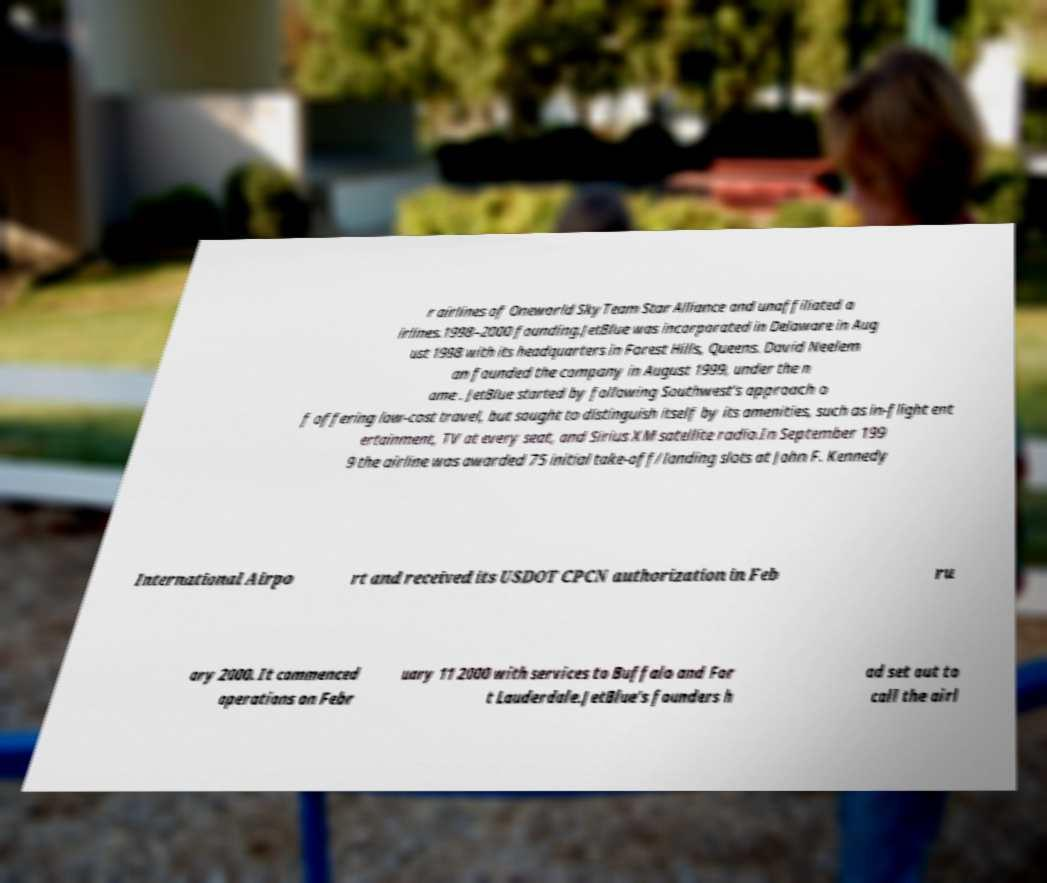Can you accurately transcribe the text from the provided image for me? r airlines of Oneworld SkyTeam Star Alliance and unaffiliated a irlines.1998–2000 founding.JetBlue was incorporated in Delaware in Aug ust 1998 with its headquarters in Forest Hills, Queens. David Neelem an founded the company in August 1999, under the n ame . JetBlue started by following Southwest's approach o f offering low-cost travel, but sought to distinguish itself by its amenities, such as in-flight ent ertainment, TV at every seat, and Sirius XM satellite radio.In September 199 9 the airline was awarded 75 initial take-off/landing slots at John F. Kennedy International Airpo rt and received its USDOT CPCN authorization in Feb ru ary 2000. It commenced operations on Febr uary 11 2000 with services to Buffalo and For t Lauderdale.JetBlue's founders h ad set out to call the airl 